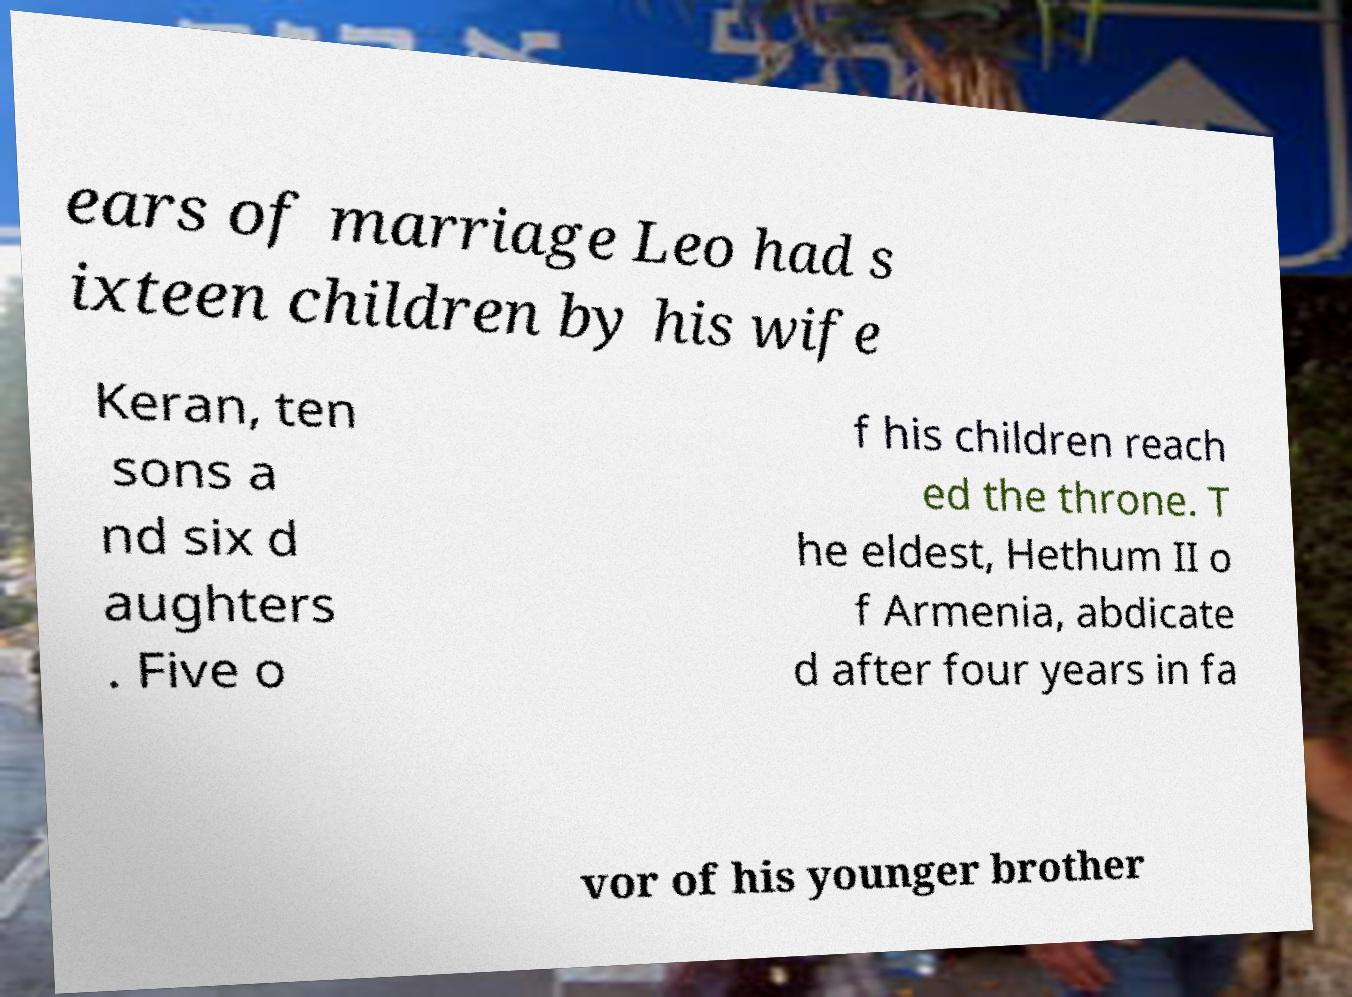There's text embedded in this image that I need extracted. Can you transcribe it verbatim? ears of marriage Leo had s ixteen children by his wife Keran, ten sons a nd six d aughters . Five o f his children reach ed the throne. T he eldest, Hethum II o f Armenia, abdicate d after four years in fa vor of his younger brother 